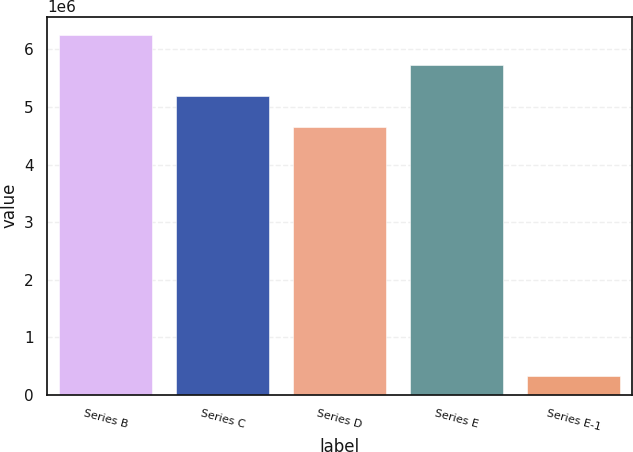Convert chart to OTSL. <chart><loc_0><loc_0><loc_500><loc_500><bar_chart><fcel>Series B<fcel>Series C<fcel>Series D<fcel>Series E<fcel>Series E-1<nl><fcel>6.25759e+06<fcel>5.18581e+06<fcel>4.64993e+06<fcel>5.7217e+06<fcel>325159<nl></chart> 